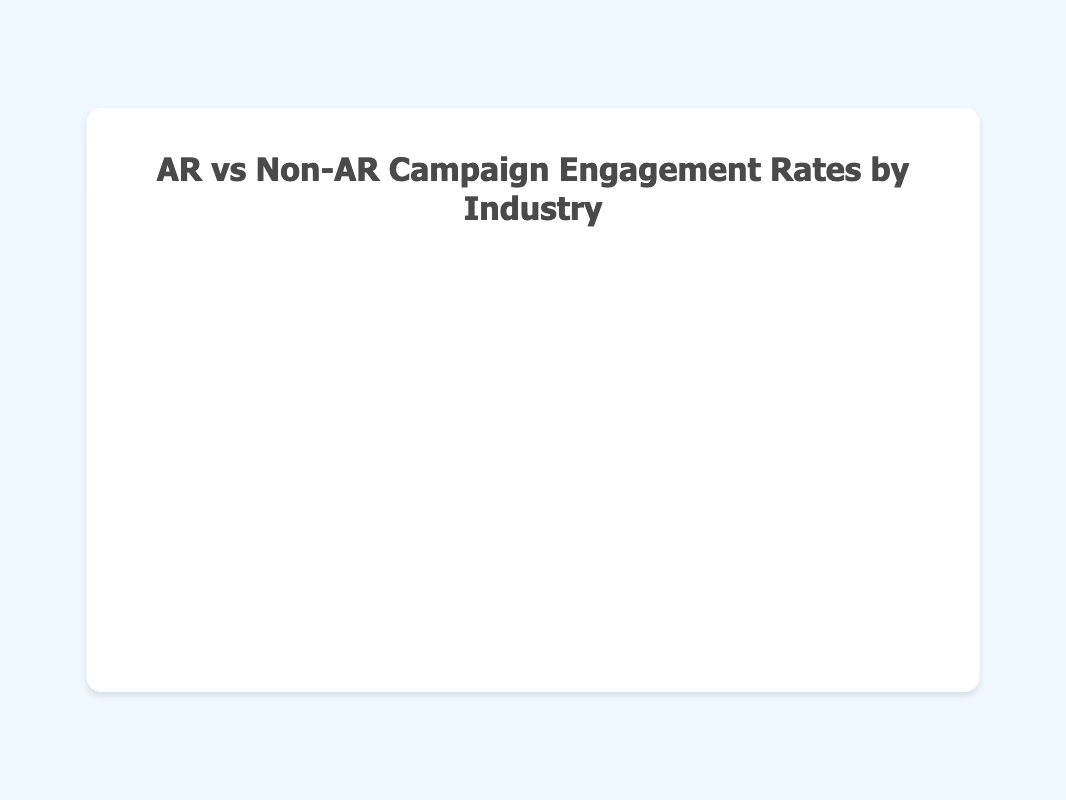Which industry has the highest AR campaign engagement rate? Look for the highest x-value in the chart, which represents the AR campaign engagement rate. The highest x-value is 17.3%, corresponding to the Real Estate industry.
Answer: Real Estate Which industry has the smallest number of AR campaigns? The size of the bubble represents the number of AR campaigns. The smallest bubble, which means the fewest AR campaigns, belongs to the Automotive industry with 30 campaigns.
Answer: Automotive What is the difference in engagement rates between AR and non-AR campaigns in the Tourism industry? Locate the Tourism industry bubble and note the AR engagement rate (15.1%) and non-AR engagement rate (7.2%). The difference is calculated as 15.1% - 7.2% = 7.9%.
Answer: 7.9% How many industries have AR campaign engagement rates above 15%? Identify the bubbles with x-values above 15%. These industries are Real Estate (17.3%), Tourism (15.1%), and Healthcare (16.4%). There are 3 industries.
Answer: 3 Compare the engagement rates for AR campaigns in Retail and Education. Which one is higher? Check the x-values for Retail (14.2%) and Education (13.7%). The Retail industry's AR campaign engagement rate is higher.
Answer: Retail Do all industries show a higher engagement rate for AR campaigns compared to non-AR campaigns? Compare the x-value (AR engagement rate) and y-value (non-AR engagement rate) for each bubble. In all cases, the x-value is greater than the y-value, indicating higher engagement rates for AR campaigns in every industry.
Answer: Yes What is the average non-AR campaign engagement rate across all industries? Calculate the average of the y-values: (6.5 + 5.7 + 8.1 + 7.2 + 6.9 + 7.8)/6 = 42.2/6 = 7.03%.
Answer: 7.03% Which industry shows the smallest improvement in engagement rates when moving from non-AR to AR campaigns? Calculate the difference between AR and non-AR engagement rates for each industry and identify the smallest difference. Automotive has AR (12.5%) and non-AR (5.7%), so the difference is 6.8%, which is the smallest among all industries.
Answer: Automotive 